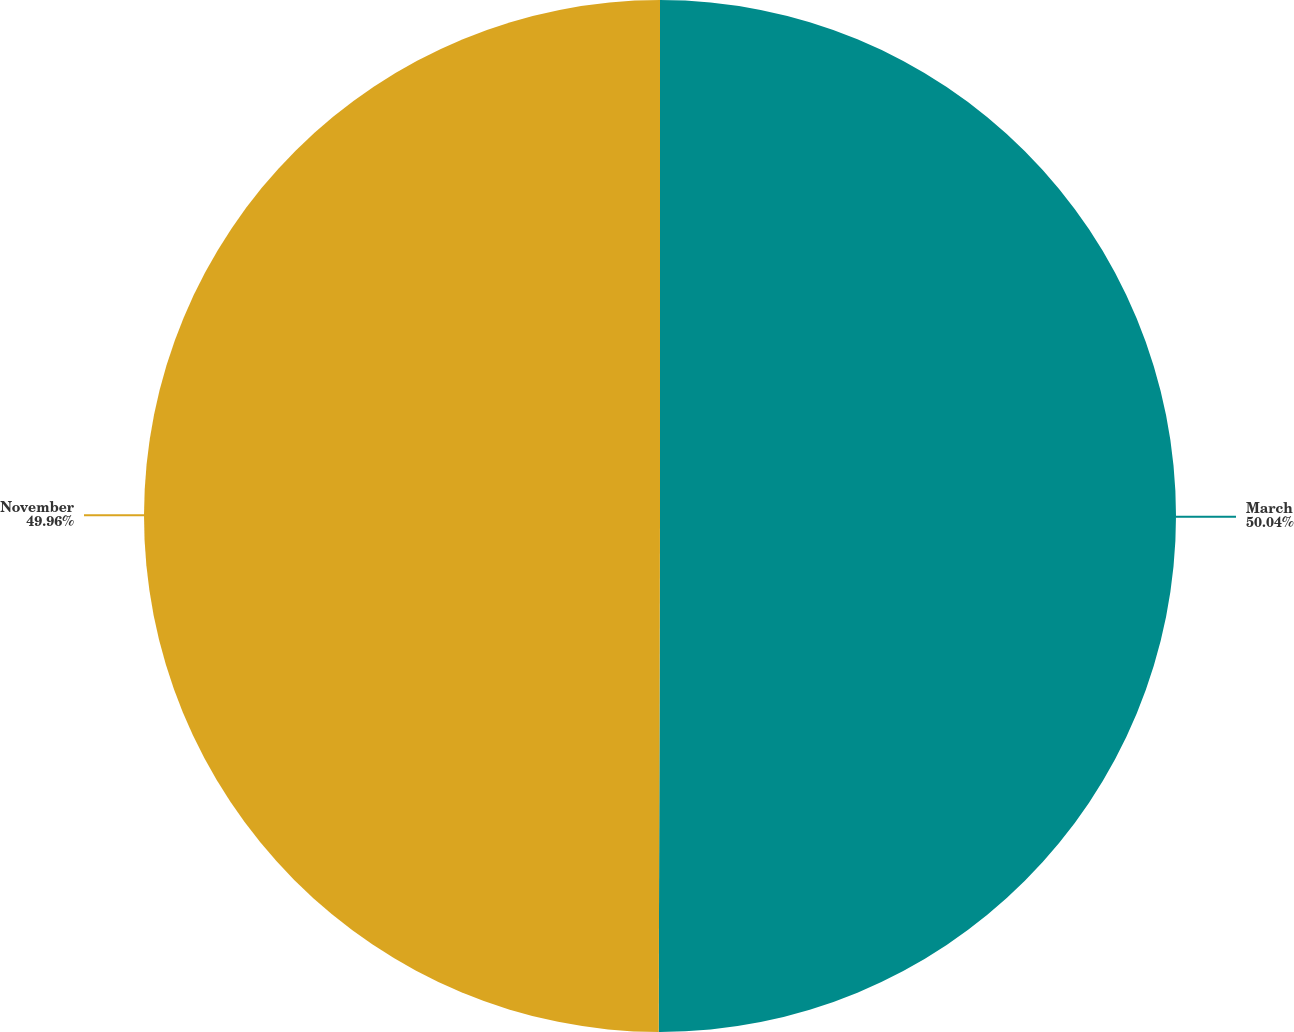Convert chart. <chart><loc_0><loc_0><loc_500><loc_500><pie_chart><fcel>March<fcel>November<nl><fcel>50.04%<fcel>49.96%<nl></chart> 